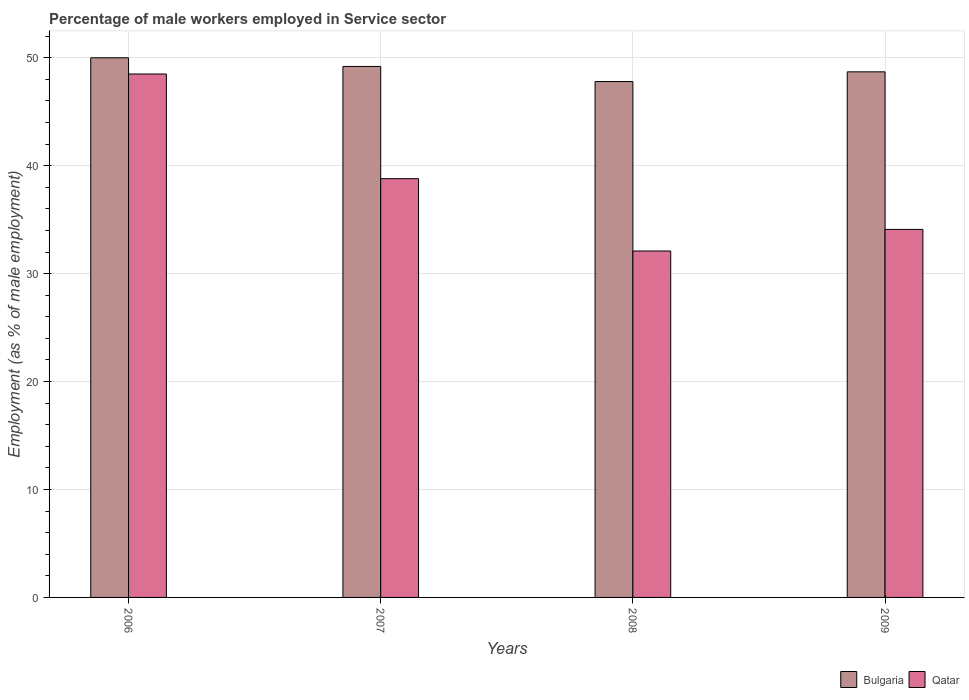How many different coloured bars are there?
Provide a succinct answer. 2. Are the number of bars per tick equal to the number of legend labels?
Ensure brevity in your answer.  Yes. How many bars are there on the 4th tick from the right?
Ensure brevity in your answer.  2. In how many cases, is the number of bars for a given year not equal to the number of legend labels?
Provide a succinct answer. 0. What is the percentage of male workers employed in Service sector in Qatar in 2006?
Your answer should be compact. 48.5. Across all years, what is the maximum percentage of male workers employed in Service sector in Bulgaria?
Keep it short and to the point. 50. Across all years, what is the minimum percentage of male workers employed in Service sector in Qatar?
Your answer should be very brief. 32.1. In which year was the percentage of male workers employed in Service sector in Qatar maximum?
Make the answer very short. 2006. In which year was the percentage of male workers employed in Service sector in Bulgaria minimum?
Provide a short and direct response. 2008. What is the total percentage of male workers employed in Service sector in Qatar in the graph?
Make the answer very short. 153.5. What is the difference between the percentage of male workers employed in Service sector in Bulgaria in 2006 and that in 2008?
Offer a very short reply. 2.2. What is the difference between the percentage of male workers employed in Service sector in Qatar in 2007 and the percentage of male workers employed in Service sector in Bulgaria in 2009?
Your answer should be compact. -9.9. What is the average percentage of male workers employed in Service sector in Qatar per year?
Offer a very short reply. 38.37. In the year 2009, what is the difference between the percentage of male workers employed in Service sector in Qatar and percentage of male workers employed in Service sector in Bulgaria?
Provide a succinct answer. -14.6. In how many years, is the percentage of male workers employed in Service sector in Qatar greater than 24 %?
Your answer should be very brief. 4. What is the ratio of the percentage of male workers employed in Service sector in Bulgaria in 2006 to that in 2007?
Give a very brief answer. 1.02. Is the percentage of male workers employed in Service sector in Qatar in 2006 less than that in 2009?
Provide a succinct answer. No. Is the difference between the percentage of male workers employed in Service sector in Qatar in 2006 and 2007 greater than the difference between the percentage of male workers employed in Service sector in Bulgaria in 2006 and 2007?
Make the answer very short. Yes. What is the difference between the highest and the second highest percentage of male workers employed in Service sector in Bulgaria?
Ensure brevity in your answer.  0.8. What is the difference between the highest and the lowest percentage of male workers employed in Service sector in Qatar?
Ensure brevity in your answer.  16.4. In how many years, is the percentage of male workers employed in Service sector in Bulgaria greater than the average percentage of male workers employed in Service sector in Bulgaria taken over all years?
Make the answer very short. 2. What does the 1st bar from the left in 2009 represents?
Provide a succinct answer. Bulgaria. What does the 2nd bar from the right in 2006 represents?
Your answer should be compact. Bulgaria. Are all the bars in the graph horizontal?
Your answer should be compact. No. How many years are there in the graph?
Your response must be concise. 4. What is the difference between two consecutive major ticks on the Y-axis?
Offer a terse response. 10. Are the values on the major ticks of Y-axis written in scientific E-notation?
Your answer should be very brief. No. Does the graph contain any zero values?
Offer a very short reply. No. How many legend labels are there?
Offer a very short reply. 2. What is the title of the graph?
Your answer should be very brief. Percentage of male workers employed in Service sector. Does "Andorra" appear as one of the legend labels in the graph?
Provide a short and direct response. No. What is the label or title of the X-axis?
Ensure brevity in your answer.  Years. What is the label or title of the Y-axis?
Your answer should be very brief. Employment (as % of male employment). What is the Employment (as % of male employment) of Qatar in 2006?
Your response must be concise. 48.5. What is the Employment (as % of male employment) in Bulgaria in 2007?
Offer a very short reply. 49.2. What is the Employment (as % of male employment) of Qatar in 2007?
Ensure brevity in your answer.  38.8. What is the Employment (as % of male employment) of Bulgaria in 2008?
Your response must be concise. 47.8. What is the Employment (as % of male employment) in Qatar in 2008?
Provide a succinct answer. 32.1. What is the Employment (as % of male employment) in Bulgaria in 2009?
Offer a very short reply. 48.7. What is the Employment (as % of male employment) of Qatar in 2009?
Make the answer very short. 34.1. Across all years, what is the maximum Employment (as % of male employment) in Bulgaria?
Provide a short and direct response. 50. Across all years, what is the maximum Employment (as % of male employment) of Qatar?
Keep it short and to the point. 48.5. Across all years, what is the minimum Employment (as % of male employment) of Bulgaria?
Keep it short and to the point. 47.8. Across all years, what is the minimum Employment (as % of male employment) in Qatar?
Offer a very short reply. 32.1. What is the total Employment (as % of male employment) of Bulgaria in the graph?
Offer a terse response. 195.7. What is the total Employment (as % of male employment) of Qatar in the graph?
Give a very brief answer. 153.5. What is the difference between the Employment (as % of male employment) in Qatar in 2006 and that in 2007?
Offer a very short reply. 9.7. What is the difference between the Employment (as % of male employment) in Qatar in 2007 and that in 2008?
Your answer should be very brief. 6.7. What is the difference between the Employment (as % of male employment) in Bulgaria in 2008 and that in 2009?
Keep it short and to the point. -0.9. What is the difference between the Employment (as % of male employment) in Qatar in 2008 and that in 2009?
Ensure brevity in your answer.  -2. What is the difference between the Employment (as % of male employment) in Bulgaria in 2007 and the Employment (as % of male employment) in Qatar in 2008?
Your answer should be compact. 17.1. What is the difference between the Employment (as % of male employment) of Bulgaria in 2007 and the Employment (as % of male employment) of Qatar in 2009?
Provide a short and direct response. 15.1. What is the average Employment (as % of male employment) in Bulgaria per year?
Keep it short and to the point. 48.92. What is the average Employment (as % of male employment) of Qatar per year?
Provide a short and direct response. 38.38. In the year 2007, what is the difference between the Employment (as % of male employment) of Bulgaria and Employment (as % of male employment) of Qatar?
Provide a short and direct response. 10.4. What is the ratio of the Employment (as % of male employment) of Bulgaria in 2006 to that in 2007?
Your answer should be compact. 1.02. What is the ratio of the Employment (as % of male employment) of Qatar in 2006 to that in 2007?
Your answer should be compact. 1.25. What is the ratio of the Employment (as % of male employment) of Bulgaria in 2006 to that in 2008?
Your answer should be compact. 1.05. What is the ratio of the Employment (as % of male employment) in Qatar in 2006 to that in 2008?
Ensure brevity in your answer.  1.51. What is the ratio of the Employment (as % of male employment) in Bulgaria in 2006 to that in 2009?
Provide a succinct answer. 1.03. What is the ratio of the Employment (as % of male employment) of Qatar in 2006 to that in 2009?
Your response must be concise. 1.42. What is the ratio of the Employment (as % of male employment) in Bulgaria in 2007 to that in 2008?
Provide a short and direct response. 1.03. What is the ratio of the Employment (as % of male employment) in Qatar in 2007 to that in 2008?
Make the answer very short. 1.21. What is the ratio of the Employment (as % of male employment) of Bulgaria in 2007 to that in 2009?
Provide a short and direct response. 1.01. What is the ratio of the Employment (as % of male employment) in Qatar in 2007 to that in 2009?
Provide a short and direct response. 1.14. What is the ratio of the Employment (as % of male employment) in Bulgaria in 2008 to that in 2009?
Your answer should be compact. 0.98. What is the ratio of the Employment (as % of male employment) of Qatar in 2008 to that in 2009?
Keep it short and to the point. 0.94. What is the difference between the highest and the second highest Employment (as % of male employment) in Bulgaria?
Offer a very short reply. 0.8. What is the difference between the highest and the second highest Employment (as % of male employment) in Qatar?
Your answer should be very brief. 9.7. 